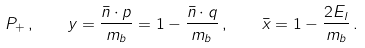Convert formula to latex. <formula><loc_0><loc_0><loc_500><loc_500>P _ { + } \, , \quad y = \frac { \bar { n } \cdot p } { m _ { b } } = 1 - \frac { \bar { n } \cdot q } { m _ { b } } \, , \quad \bar { x } = 1 - \frac { 2 E _ { l } } { m _ { b } } \, .</formula> 